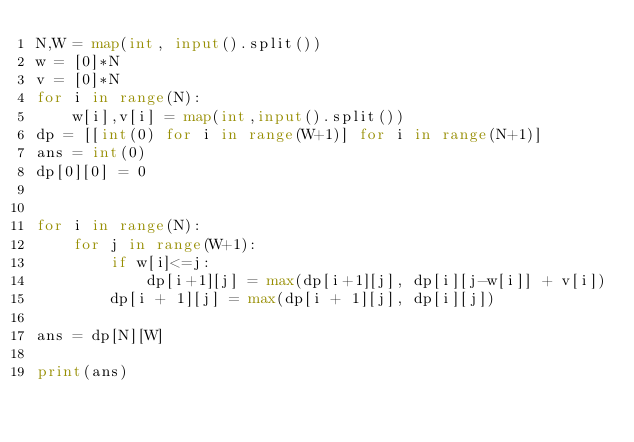Convert code to text. <code><loc_0><loc_0><loc_500><loc_500><_Python_>N,W = map(int, input().split())
w = [0]*N
v = [0]*N
for i in range(N):
    w[i],v[i] = map(int,input().split())
dp = [[int(0) for i in range(W+1)] for i in range(N+1)]
ans = int(0)
dp[0][0] = 0


for i in range(N):
    for j in range(W+1):
        if w[i]<=j:
            dp[i+1][j] = max(dp[i+1][j], dp[i][j-w[i]] + v[i])
        dp[i + 1][j] = max(dp[i + 1][j], dp[i][j])

ans = dp[N][W]

print(ans)</code> 